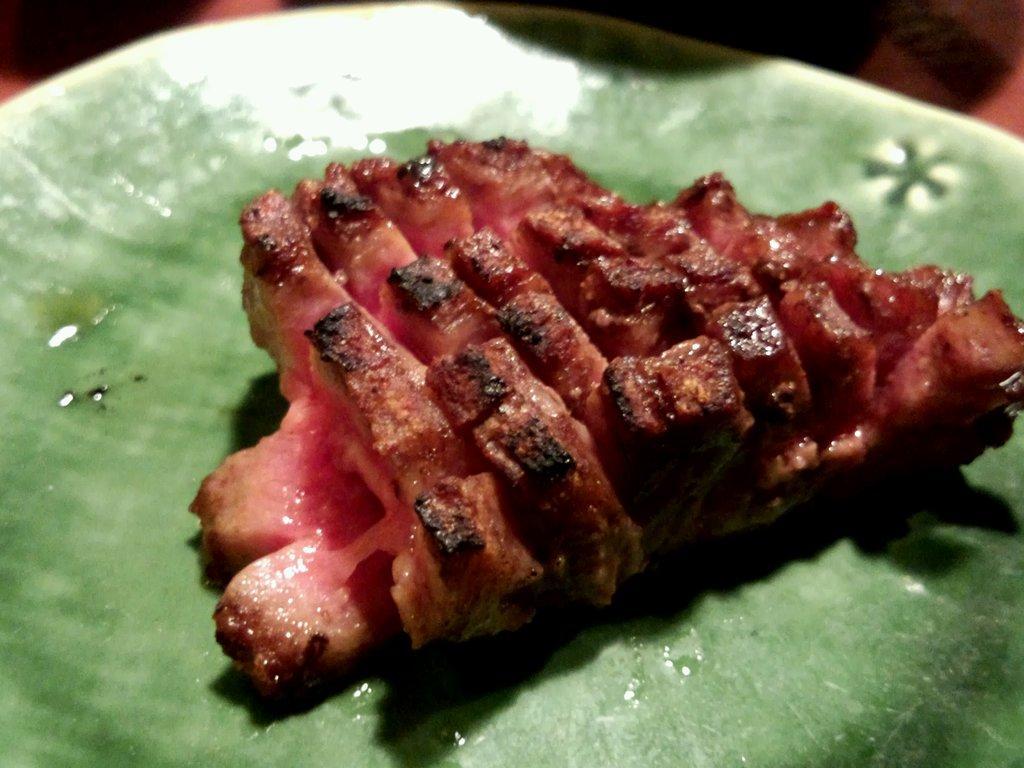Can you describe this image briefly? In this picture we can see food in the plate. 